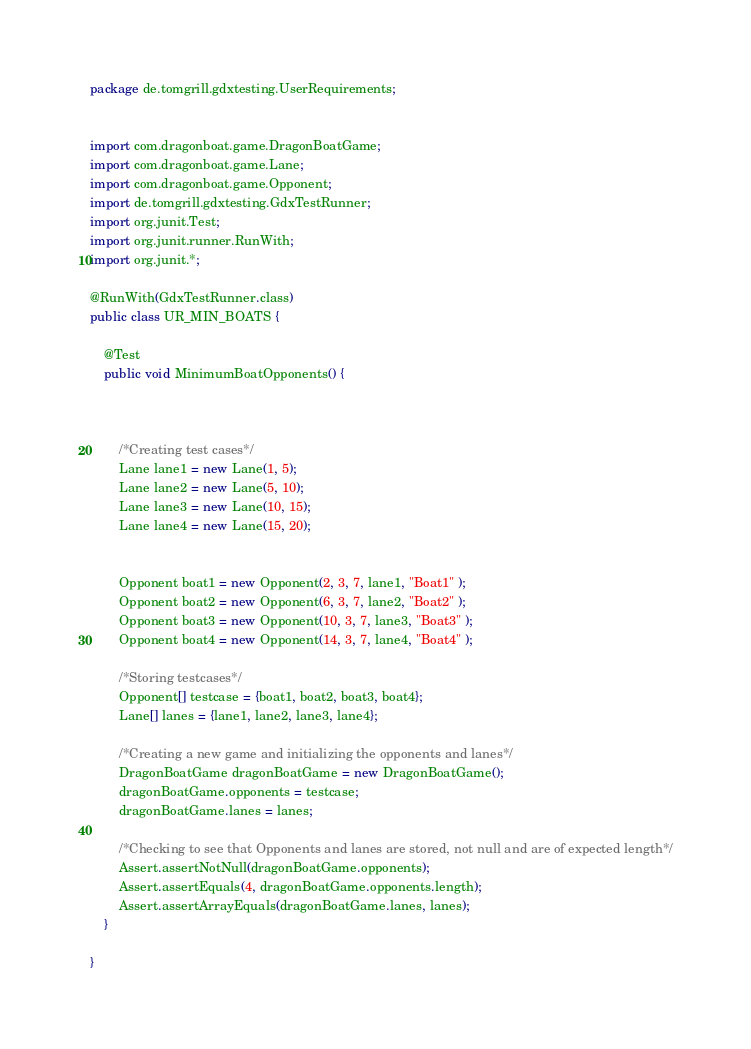Convert code to text. <code><loc_0><loc_0><loc_500><loc_500><_Java_>package de.tomgrill.gdxtesting.UserRequirements;


import com.dragonboat.game.DragonBoatGame;
import com.dragonboat.game.Lane;
import com.dragonboat.game.Opponent;
import de.tomgrill.gdxtesting.GdxTestRunner;
import org.junit.Test;
import org.junit.runner.RunWith;
import org.junit.*;

@RunWith(GdxTestRunner.class)
public class UR_MIN_BOATS {

    @Test
    public void MinimumBoatOpponents() {



        /*Creating test cases*/
        Lane lane1 = new Lane(1, 5);
        Lane lane2 = new Lane(5, 10);
        Lane lane3 = new Lane(10, 15);
        Lane lane4 = new Lane(15, 20);


        Opponent boat1 = new Opponent(2, 3, 7, lane1, "Boat1" );
        Opponent boat2 = new Opponent(6, 3, 7, lane2, "Boat2" );
        Opponent boat3 = new Opponent(10, 3, 7, lane3, "Boat3" );
        Opponent boat4 = new Opponent(14, 3, 7, lane4, "Boat4" );

        /*Storing testcases*/
        Opponent[] testcase = {boat1, boat2, boat3, boat4};
        Lane[] lanes = {lane1, lane2, lane3, lane4};

        /*Creating a new game and initializing the opponents and lanes*/
        DragonBoatGame dragonBoatGame = new DragonBoatGame();
        dragonBoatGame.opponents = testcase;
        dragonBoatGame.lanes = lanes;

        /*Checking to see that Opponents and lanes are stored, not null and are of expected length*/
        Assert.assertNotNull(dragonBoatGame.opponents);
        Assert.assertEquals(4, dragonBoatGame.opponents.length);
        Assert.assertArrayEquals(dragonBoatGame.lanes, lanes);
    }

}
</code> 